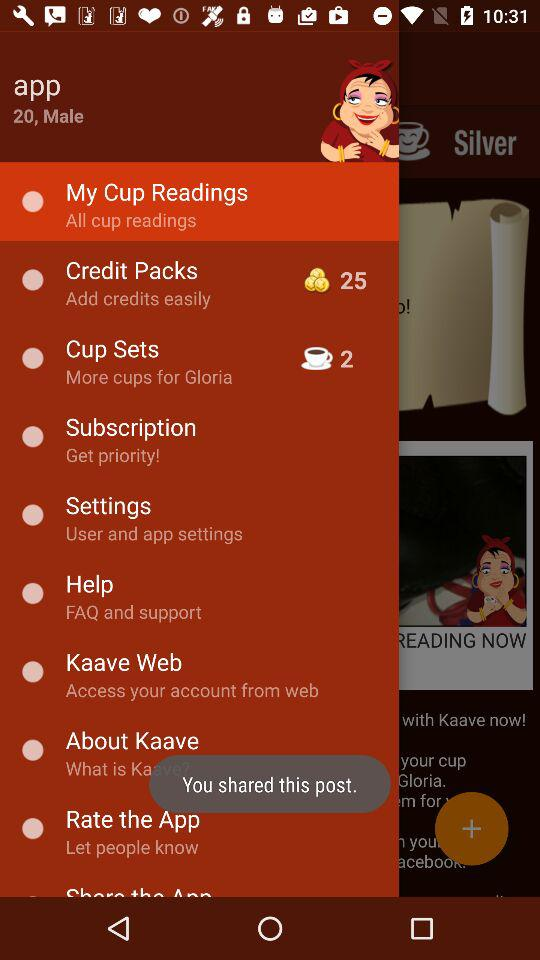How old is the person? The person is 20 years old. 